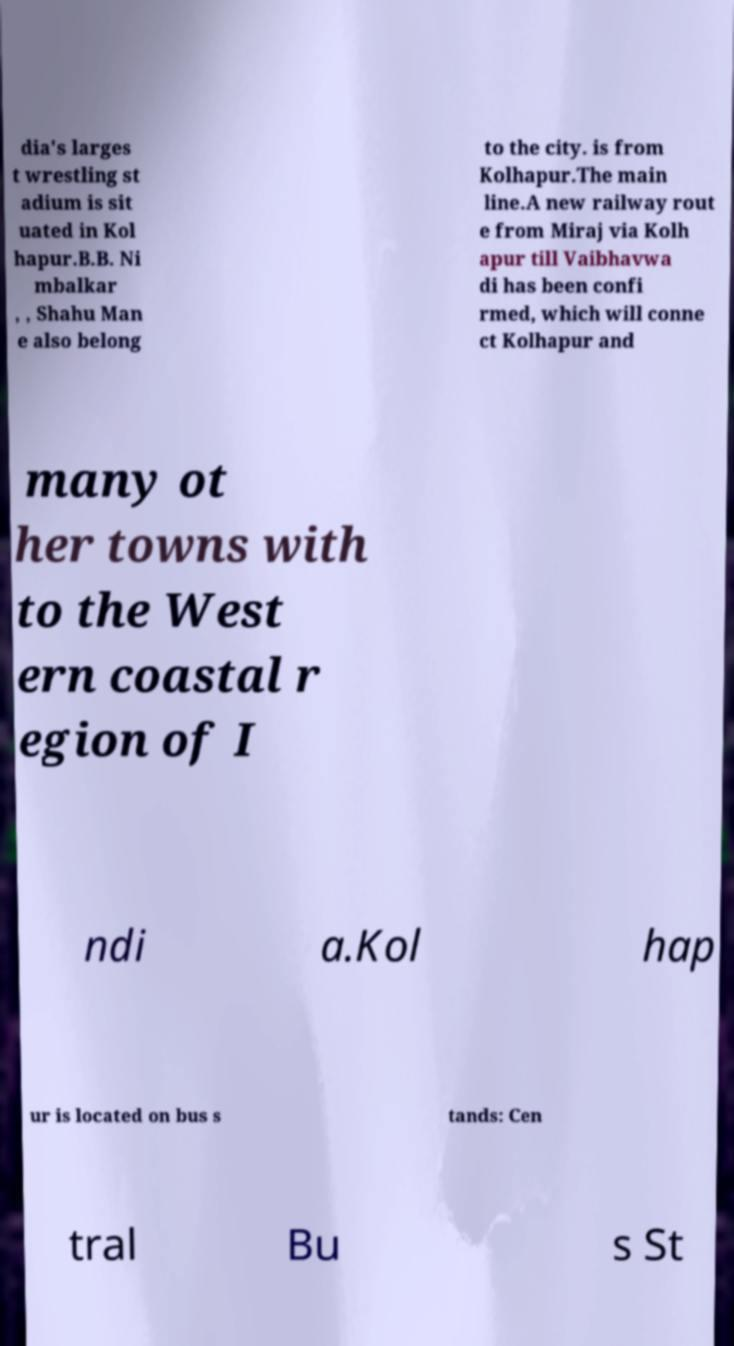Please identify and transcribe the text found in this image. dia's larges t wrestling st adium is sit uated in Kol hapur.B.B. Ni mbalkar , , Shahu Man e also belong to the city. is from Kolhapur.The main line.A new railway rout e from Miraj via Kolh apur till Vaibhavwa di has been confi rmed, which will conne ct Kolhapur and many ot her towns with to the West ern coastal r egion of I ndi a.Kol hap ur is located on bus s tands: Cen tral Bu s St 